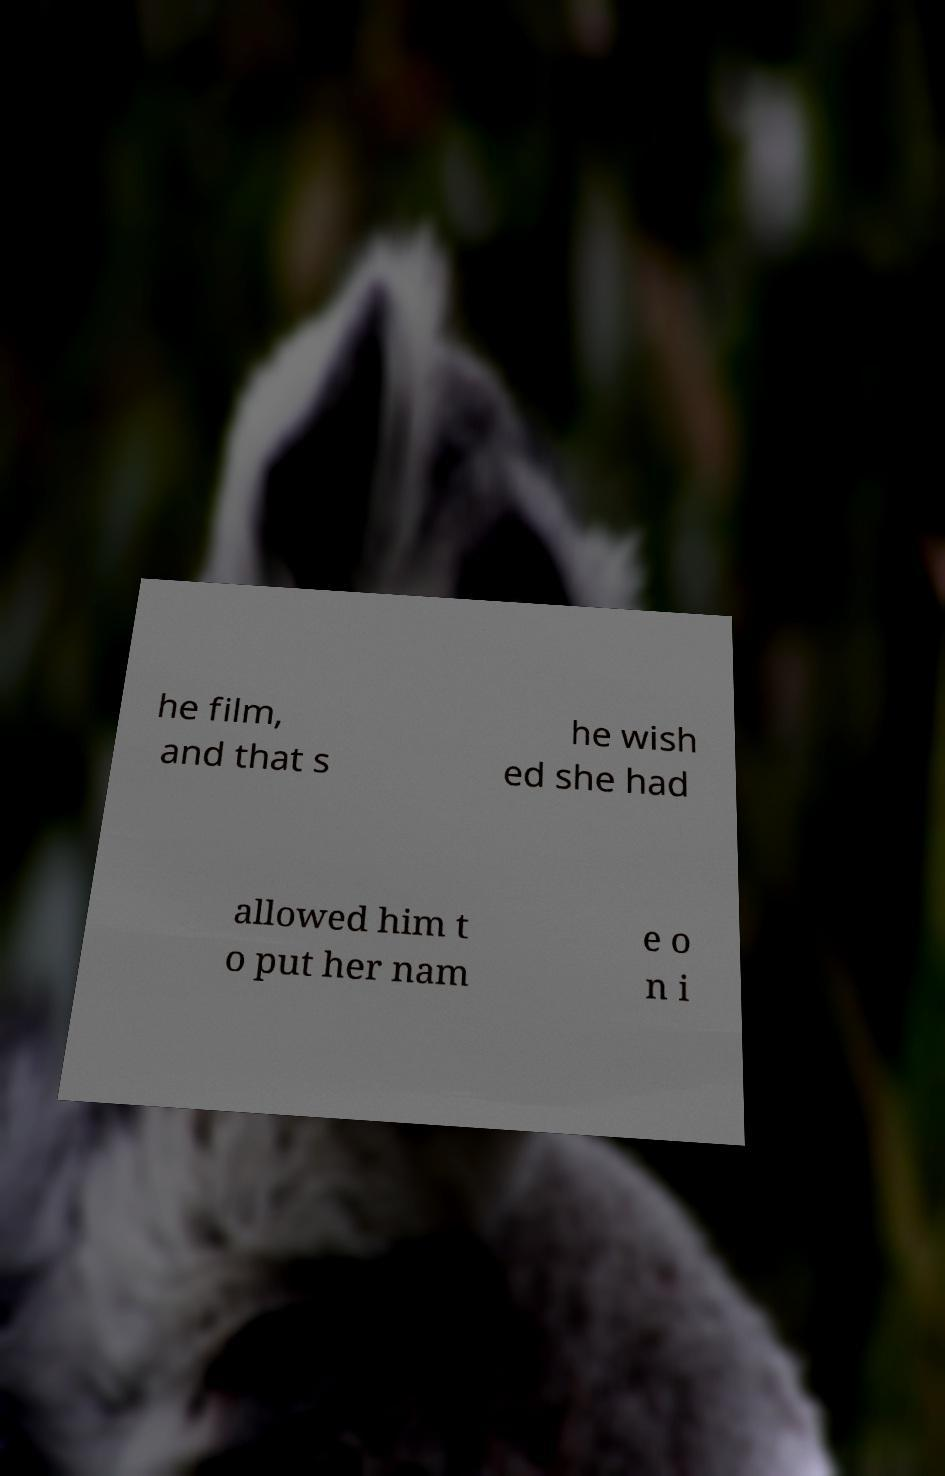Could you assist in decoding the text presented in this image and type it out clearly? he film, and that s he wish ed she had allowed him t o put her nam e o n i 